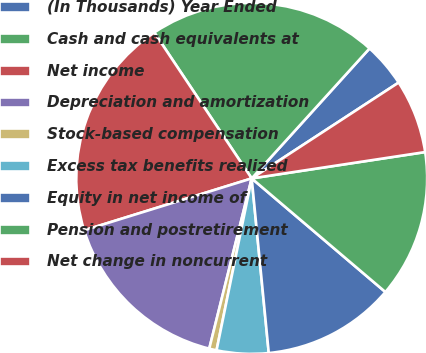Convert chart to OTSL. <chart><loc_0><loc_0><loc_500><loc_500><pie_chart><fcel>(In Thousands) Year Ended<fcel>Cash and cash equivalents at<fcel>Net income<fcel>Depreciation and amortization<fcel>Stock-based compensation<fcel>Excess tax benefits realized<fcel>Equity in net income of<fcel>Pension and postretirement<fcel>Net change in noncurrent<nl><fcel>4.08%<fcel>21.09%<fcel>20.41%<fcel>16.33%<fcel>0.68%<fcel>4.76%<fcel>12.24%<fcel>13.61%<fcel>6.8%<nl></chart> 